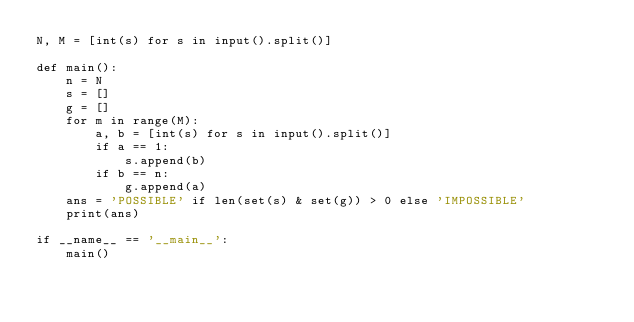<code> <loc_0><loc_0><loc_500><loc_500><_Python_>N, M = [int(s) for s in input().split()]

def main():
    n = N
    s = []
    g = []
    for m in range(M):
        a, b = [int(s) for s in input().split()]
        if a == 1:
            s.append(b)
        if b == n:
            g.append(a)
    ans = 'POSSIBLE' if len(set(s) & set(g)) > 0 else 'IMPOSSIBLE'
    print(ans)

if __name__ == '__main__':
    main()</code> 